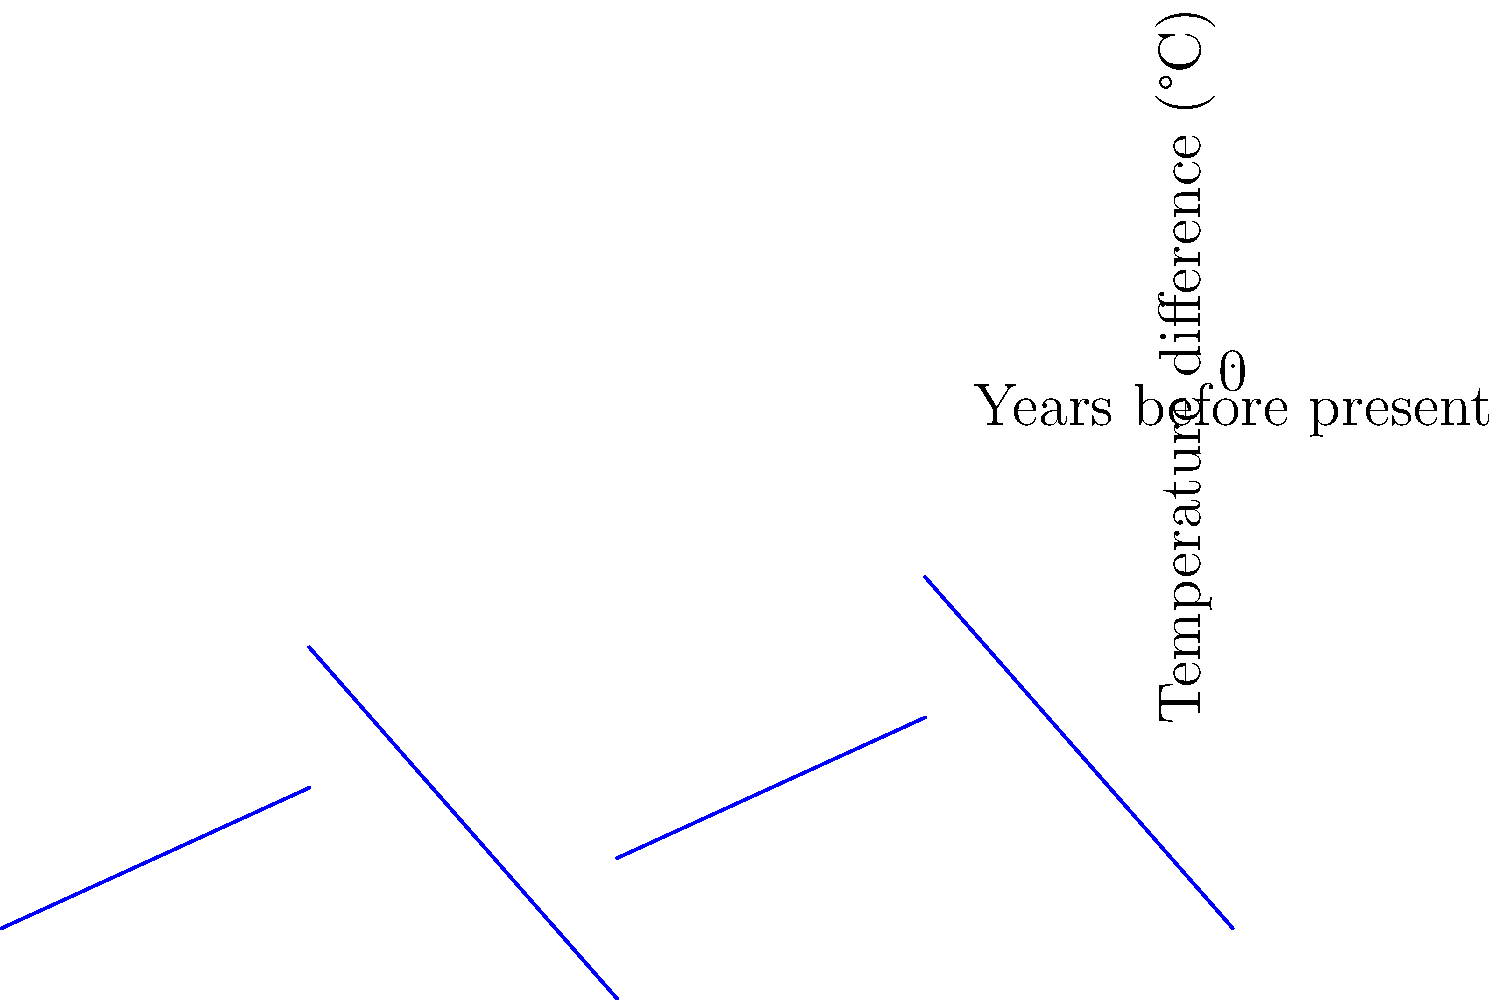Based on the ice core data represented in the graph, what general trend can be observed in Earth's temperature over the past 800,000 years? To answer this question, we need to analyze the graph step-by-step:

1. The x-axis represents "Years before present," ranging from 800,000 years ago to the present (0).
2. The y-axis shows "Temperature difference (°C)" relative to a baseline (0°C on the graph).
3. The blue line represents temperature variations over time based on ice core data.

Analyzing the graph:

1. We can see that the temperature fluctuates significantly over the 800,000-year period.
2. There are regular cycles of warming and cooling, with peaks and troughs occurring approximately every 100,000 years.
3. The amplitude of these cycles is about 8-10°C from the coldest to the warmest points.
4. Despite the fluctuations, the overall temperature range remains between about -10°C and +2°C relative to the baseline.

The key observation is that these cycles represent glacial (colder) and interglacial (warmer) periods. The regularity of these cycles suggests a long-term pattern in Earth's climate, likely driven by factors such as changes in Earth's orbit (Milankovitch cycles).

While there are significant temperature variations, there is no clear long-term warming or cooling trend visible in this data set. The cycles appear to repeat with similar magnitudes throughout the period.
Answer: Cyclic temperature fluctuations between glacial and interglacial periods 